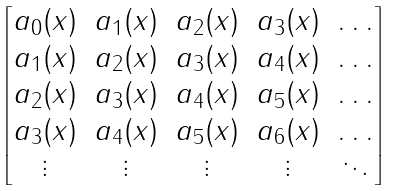<formula> <loc_0><loc_0><loc_500><loc_500>\begin{bmatrix} a _ { 0 } ( { x } ) & a _ { 1 } ( { x } ) & a _ { 2 } ( { x } ) & a _ { 3 } ( { x } ) & \dots \\ a _ { 1 } ( { x } ) & a _ { 2 } ( { x } ) & a _ { 3 } ( { x } ) & a _ { 4 } ( { x } ) & \dots \\ a _ { 2 } ( { x } ) & a _ { 3 } ( { x } ) & a _ { 4 } ( { x } ) & a _ { 5 } ( { x } ) & \dots \\ a _ { 3 } ( { x } ) & a _ { 4 } ( { x } ) & a _ { 5 } ( { x } ) & a _ { 6 } ( { x } ) & \dots \\ \vdots & \vdots & \vdots & \vdots & \ddots \end{bmatrix}</formula> 